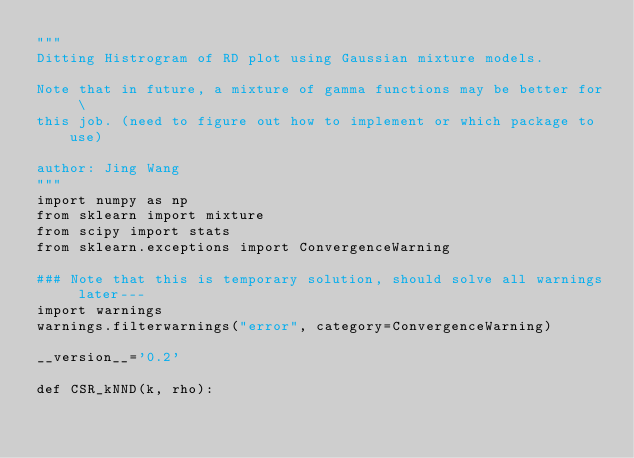Convert code to text. <code><loc_0><loc_0><loc_500><loc_500><_Python_>"""
Ditting Histrogram of RD plot using Gaussian mixture models. 

Note that in future, a mixture of gamma functions may be better for \
this job. (need to figure out how to implement or which package to use)

author: Jing Wang
"""
import numpy as np
from sklearn import mixture
from scipy import stats
from sklearn.exceptions import ConvergenceWarning

### Note that this is temporary solution, should solve all warnings later---
import warnings
warnings.filterwarnings("error", category=ConvergenceWarning)

__version__='0.2'

def CSR_kNND(k, rho):</code> 